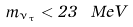<formula> <loc_0><loc_0><loc_500><loc_500>m _ { \nu _ { \tau } } < 2 3 \ M e V</formula> 